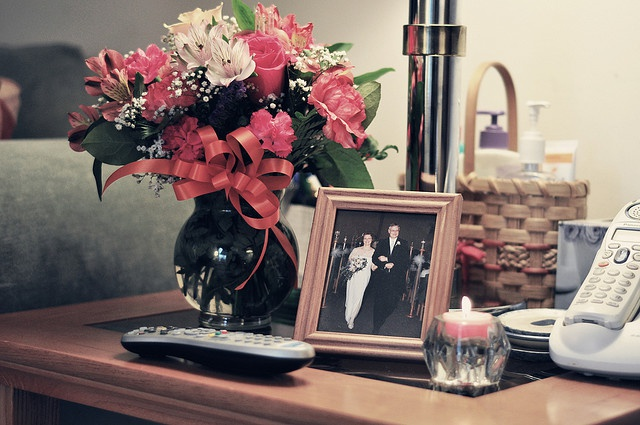Describe the objects in this image and their specific colors. I can see couch in gray, black, and darkgray tones, vase in gray, black, brown, and salmon tones, remote in gray, black, darkgray, and lightgray tones, cell phone in gray, beige, darkgray, and lightgray tones, and people in gray, black, and lightgray tones in this image. 